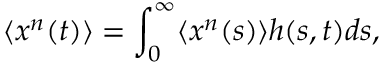Convert formula to latex. <formula><loc_0><loc_0><loc_500><loc_500>\langle x ^ { n } ( t ) \rangle = \int _ { 0 } ^ { \infty } \langle x ^ { n } ( s ) \rangle h ( s , t ) d s ,</formula> 